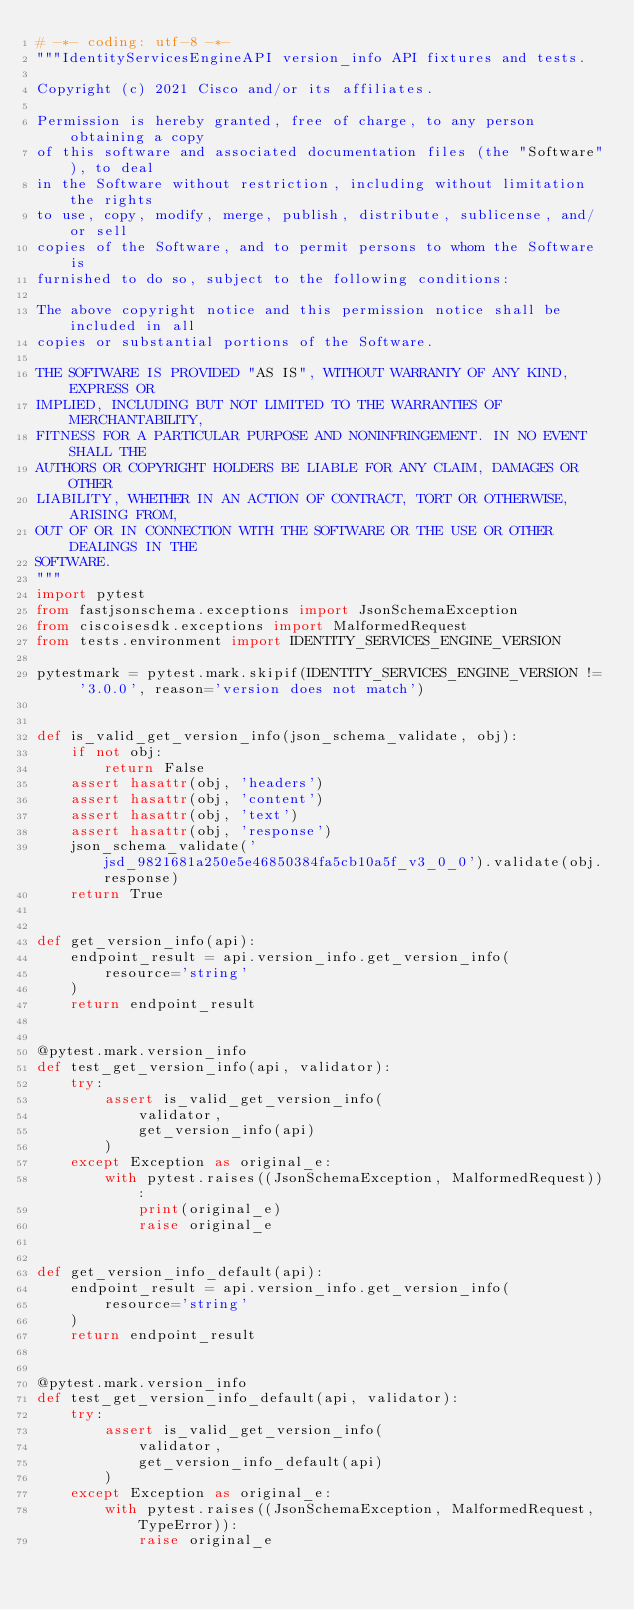<code> <loc_0><loc_0><loc_500><loc_500><_Python_># -*- coding: utf-8 -*-
"""IdentityServicesEngineAPI version_info API fixtures and tests.

Copyright (c) 2021 Cisco and/or its affiliates.

Permission is hereby granted, free of charge, to any person obtaining a copy
of this software and associated documentation files (the "Software"), to deal
in the Software without restriction, including without limitation the rights
to use, copy, modify, merge, publish, distribute, sublicense, and/or sell
copies of the Software, and to permit persons to whom the Software is
furnished to do so, subject to the following conditions:

The above copyright notice and this permission notice shall be included in all
copies or substantial portions of the Software.

THE SOFTWARE IS PROVIDED "AS IS", WITHOUT WARRANTY OF ANY KIND, EXPRESS OR
IMPLIED, INCLUDING BUT NOT LIMITED TO THE WARRANTIES OF MERCHANTABILITY,
FITNESS FOR A PARTICULAR PURPOSE AND NONINFRINGEMENT. IN NO EVENT SHALL THE
AUTHORS OR COPYRIGHT HOLDERS BE LIABLE FOR ANY CLAIM, DAMAGES OR OTHER
LIABILITY, WHETHER IN AN ACTION OF CONTRACT, TORT OR OTHERWISE, ARISING FROM,
OUT OF OR IN CONNECTION WITH THE SOFTWARE OR THE USE OR OTHER DEALINGS IN THE
SOFTWARE.
"""
import pytest
from fastjsonschema.exceptions import JsonSchemaException
from ciscoisesdk.exceptions import MalformedRequest
from tests.environment import IDENTITY_SERVICES_ENGINE_VERSION

pytestmark = pytest.mark.skipif(IDENTITY_SERVICES_ENGINE_VERSION != '3.0.0', reason='version does not match')


def is_valid_get_version_info(json_schema_validate, obj):
    if not obj:
        return False
    assert hasattr(obj, 'headers')
    assert hasattr(obj, 'content')
    assert hasattr(obj, 'text')
    assert hasattr(obj, 'response')
    json_schema_validate('jsd_9821681a250e5e46850384fa5cb10a5f_v3_0_0').validate(obj.response)
    return True


def get_version_info(api):
    endpoint_result = api.version_info.get_version_info(
        resource='string'
    )
    return endpoint_result


@pytest.mark.version_info
def test_get_version_info(api, validator):
    try:
        assert is_valid_get_version_info(
            validator,
            get_version_info(api)
        )
    except Exception as original_e:
        with pytest.raises((JsonSchemaException, MalformedRequest)):
            print(original_e)
            raise original_e


def get_version_info_default(api):
    endpoint_result = api.version_info.get_version_info(
        resource='string'
    )
    return endpoint_result


@pytest.mark.version_info
def test_get_version_info_default(api, validator):
    try:
        assert is_valid_get_version_info(
            validator,
            get_version_info_default(api)
        )
    except Exception as original_e:
        with pytest.raises((JsonSchemaException, MalformedRequest, TypeError)):
            raise original_e
</code> 